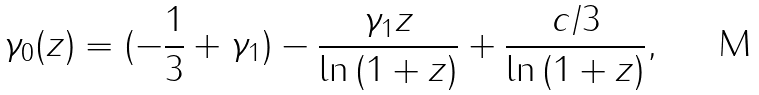<formula> <loc_0><loc_0><loc_500><loc_500>\gamma _ { 0 } ( z ) = ( - \frac { 1 } { 3 } + \gamma _ { 1 } ) - \frac { \gamma _ { 1 } z } { \ln { ( 1 + z ) } } + \frac { c / 3 } { \ln { ( 1 + z ) } } ,</formula> 